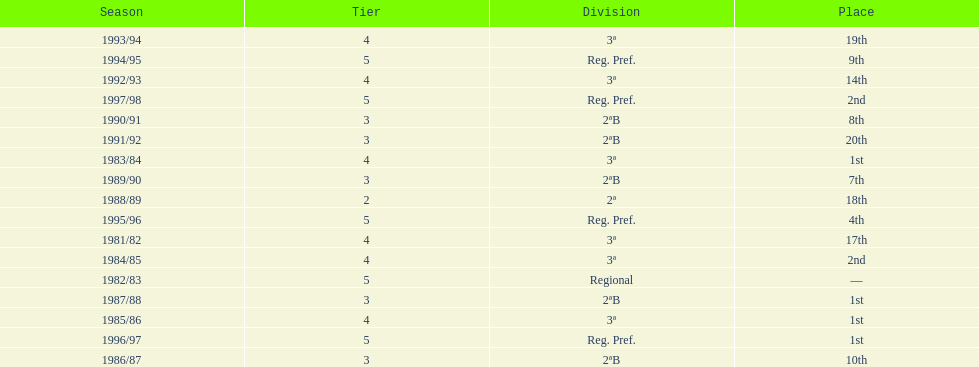When is the last year that the team has been division 2? 1991/92. 